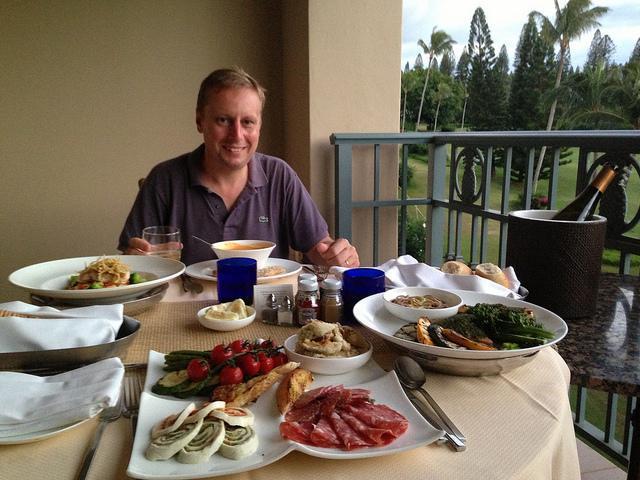How many people are shown at the table?
Give a very brief answer. 1. How many bowls are in the photo?
Give a very brief answer. 4. 